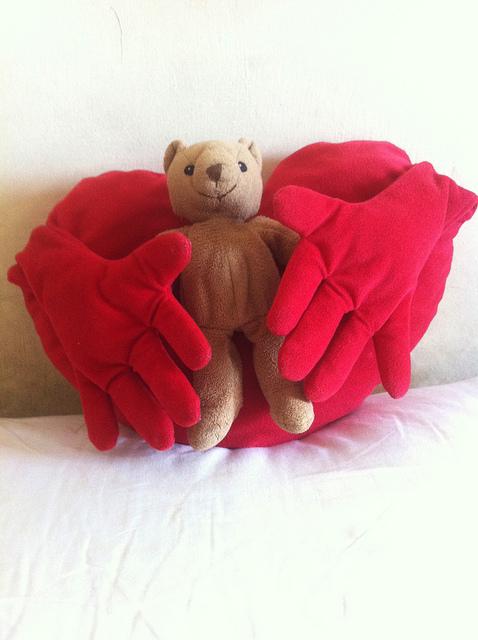How many fingers are on the heart's hand?
Write a very short answer. 5. What is the heart hugging?
Be succinct. Bear. Does this belong to an adult or child?
Give a very brief answer. Child. 